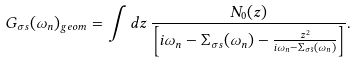<formula> <loc_0><loc_0><loc_500><loc_500>G _ { \sigma s } ( \omega _ { n } ) _ { g e o m } = \int d z \, \frac { N _ { 0 } ( z ) } { \left [ i \omega _ { n } - \Sigma _ { \sigma s } ( \omega _ { n } ) - \frac { z ^ { 2 } } { i \omega _ { n } - \Sigma _ { \sigma \bar { s } } ( \omega _ { n } ) } \right ] } .</formula> 